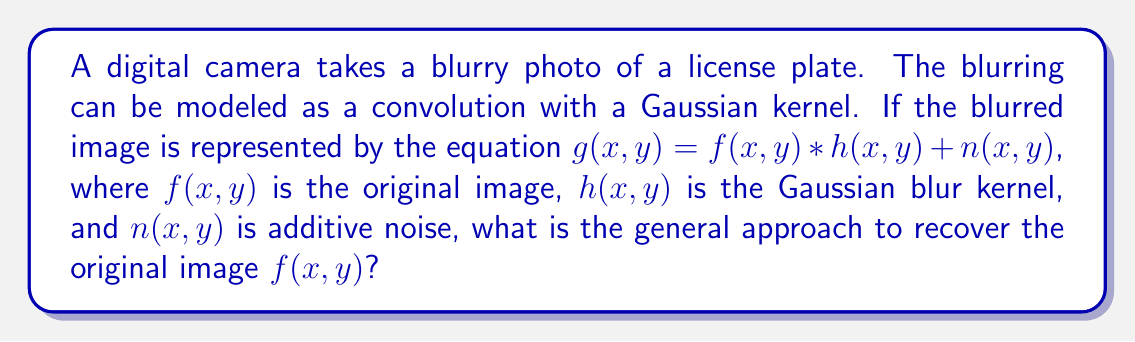Give your solution to this math problem. To recover the original image $f(x,y)$ from the blurred and noisy image $g(x,y)$, we can use deconvolution techniques. Here's a step-by-step approach:

1. Understand the problem:
   $g(x,y) = f(x,y) * h(x,y) + n(x,y)$
   where $*$ denotes convolution

2. Apply the Fourier transform to both sides:
   $G(u,v) = F(u,v) \cdot H(u,v) + N(u,v)$
   where capital letters represent the Fourier transforms of the corresponding functions

3. Isolate $F(u,v)$:
   $F(u,v) = \frac{G(u,v) - N(u,v)}{H(u,v)}$

4. The simplest approach (naive deconvolution) would be to divide both sides by $H(u,v)$:
   $\hat{F}(u,v) = \frac{G(u,v)}{H(u,v)}$

5. However, this approach amplifies noise, especially at frequencies where $H(u,v)$ is small

6. A better approach is to use regularized deconvolution, such as Wiener deconvolution:
   $\hat{F}(u,v) = \frac{H^*(u,v)}{|H(u,v)|^2 + K} \cdot G(u,v)$
   where $H^*(u,v)$ is the complex conjugate of $H(u,v)$, and $K$ is a regularization parameter

7. Apply the inverse Fourier transform to $\hat{F}(u,v)$ to obtain the estimated original image $\hat{f}(x,y)$

This approach helps recover the original image while minimizing the impact of noise and avoiding division by zero problems in the deconvolution process.
Answer: Wiener deconvolution in the frequency domain 